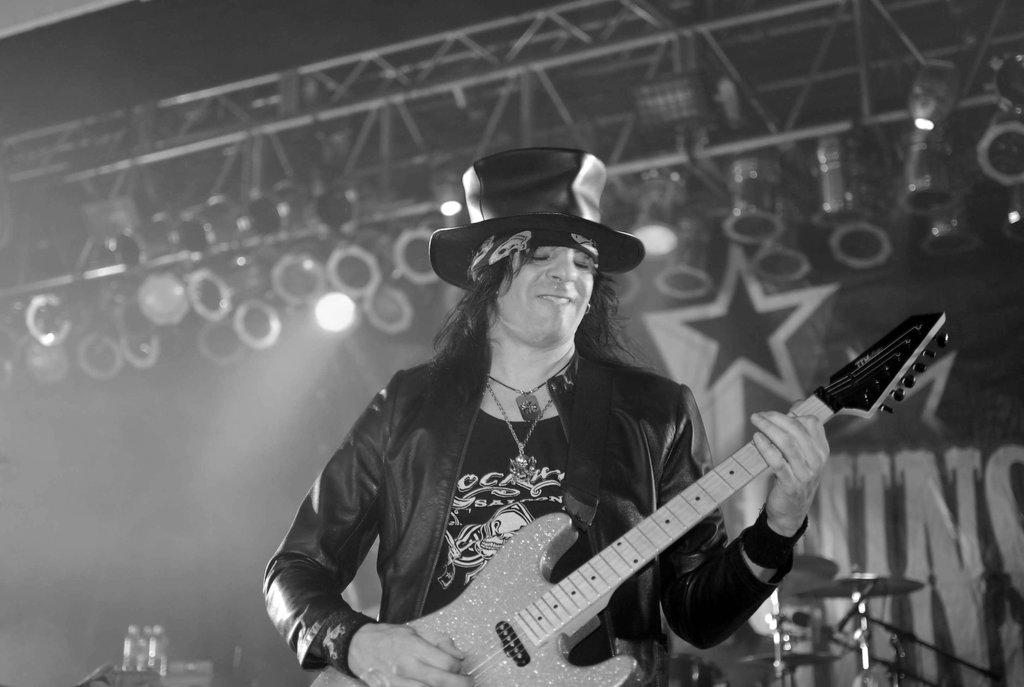What is the main subject of the image? There is a person in the image. What is the person wearing? The person is wearing a black jacket and a black hat. What is the person doing in the image? The person is playing a musical instrument. What can be seen in the background of the image? There are lights visible in the background of the image. What type of plants can be seen growing in the basket in the image? There is no basket or plants present in the image. What genre of fiction is the person reading in the image? There is no book or reading material visible in the image. 